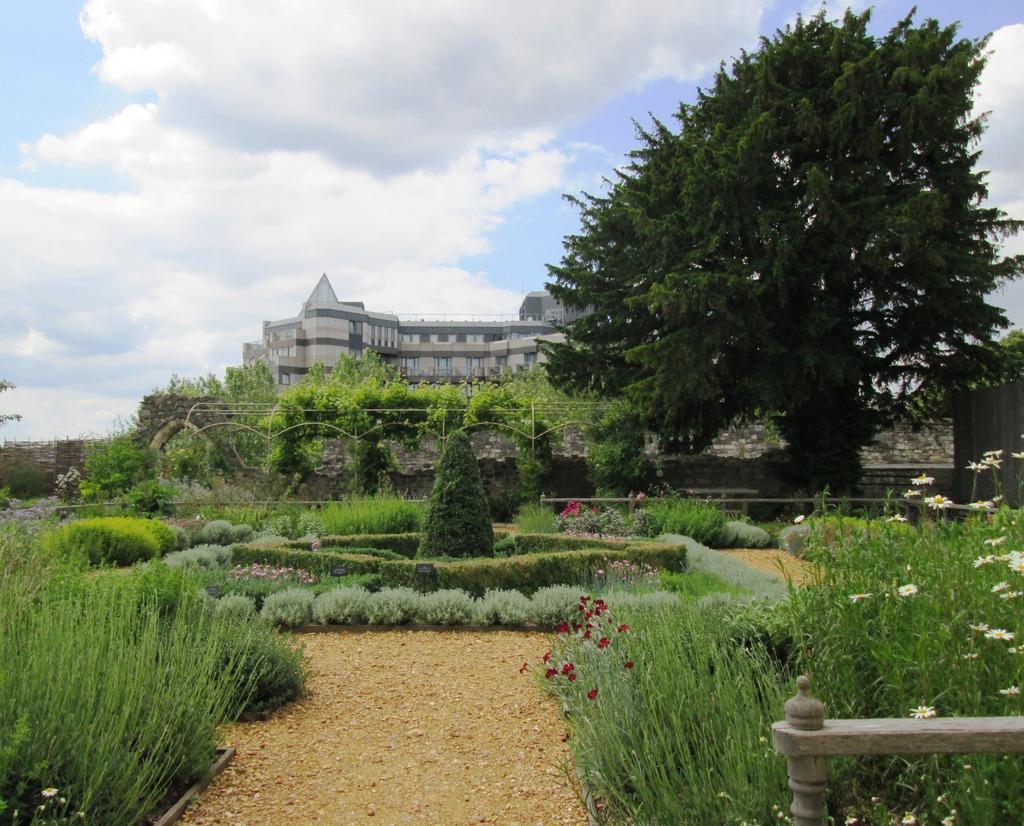Can you describe this image briefly? In this image we can see grass, fence, shrubs, trees, stone wall, building and the sky with clouds in the background. 